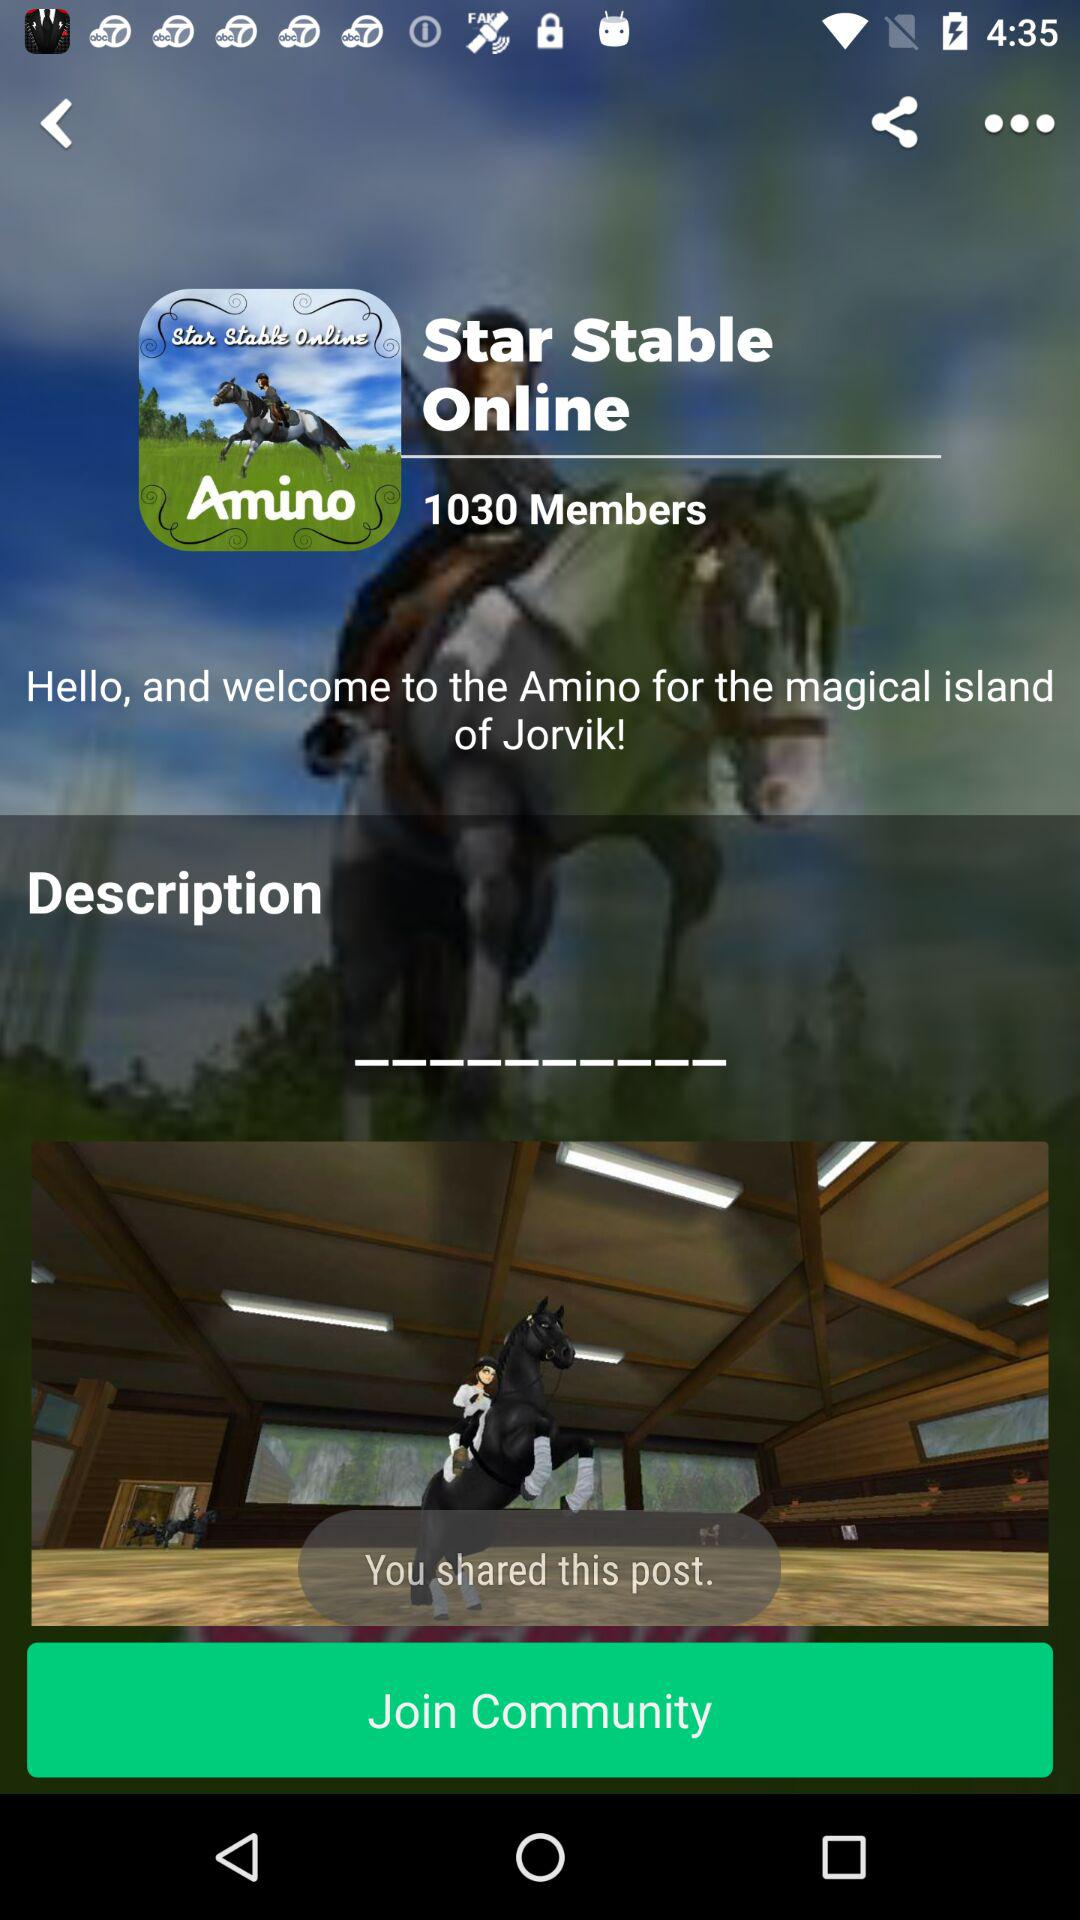What is the application name? The application name is "Star Stable Online". 